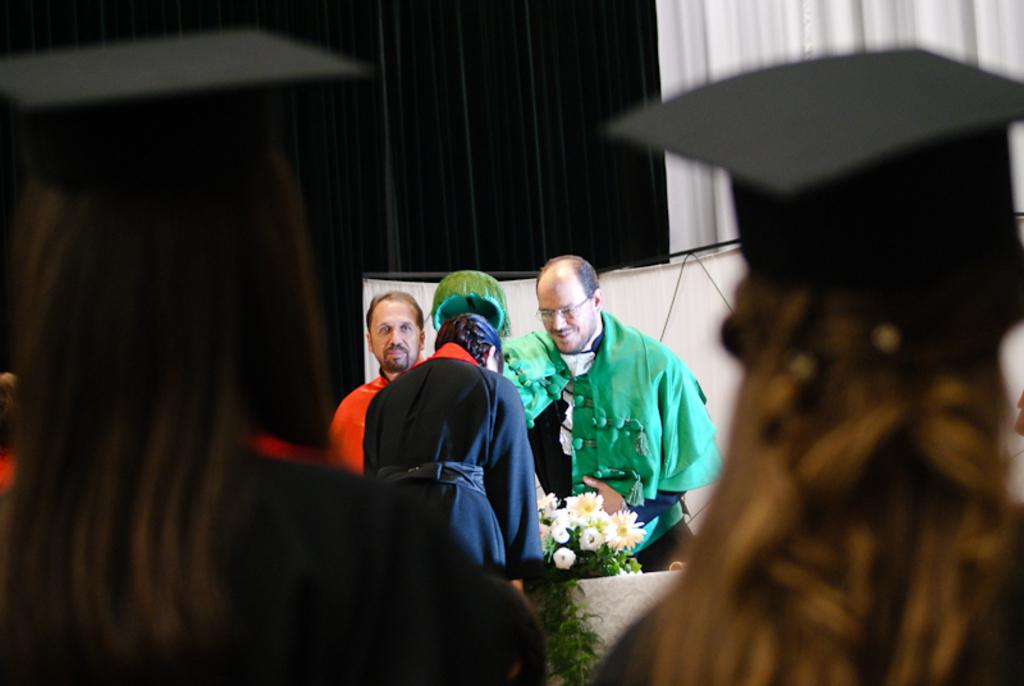What is the main subject in the foreground of the image? There is a group of people in the foreground of the image. What objects are on the floor in the foreground? There are bouquets on the floor in the foreground. What can be seen in the background of the image? There are curtains visible in the background of the image. What type of location might the image be taken in? The image is likely taken in a hall. What type of advertisement can be seen on the curtain in the image? There is no advertisement present on the curtain in the image. How does the fog affect the visibility of the people in the image? There is no fog present in the image; it is a clear scene. 